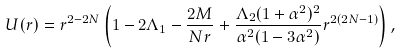Convert formula to latex. <formula><loc_0><loc_0><loc_500><loc_500>U ( r ) = r ^ { 2 - 2 N } \left ( 1 - 2 \Lambda _ { 1 } - \frac { 2 M } { N r } + \frac { \Lambda _ { 2 } ( 1 + \alpha ^ { 2 } ) ^ { 2 } } { \alpha ^ { 2 } ( 1 - 3 \alpha ^ { 2 } ) } r ^ { 2 ( 2 N - 1 ) } \right ) ,</formula> 